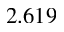Convert formula to latex. <formula><loc_0><loc_0><loc_500><loc_500>2 . 6 1 9</formula> 